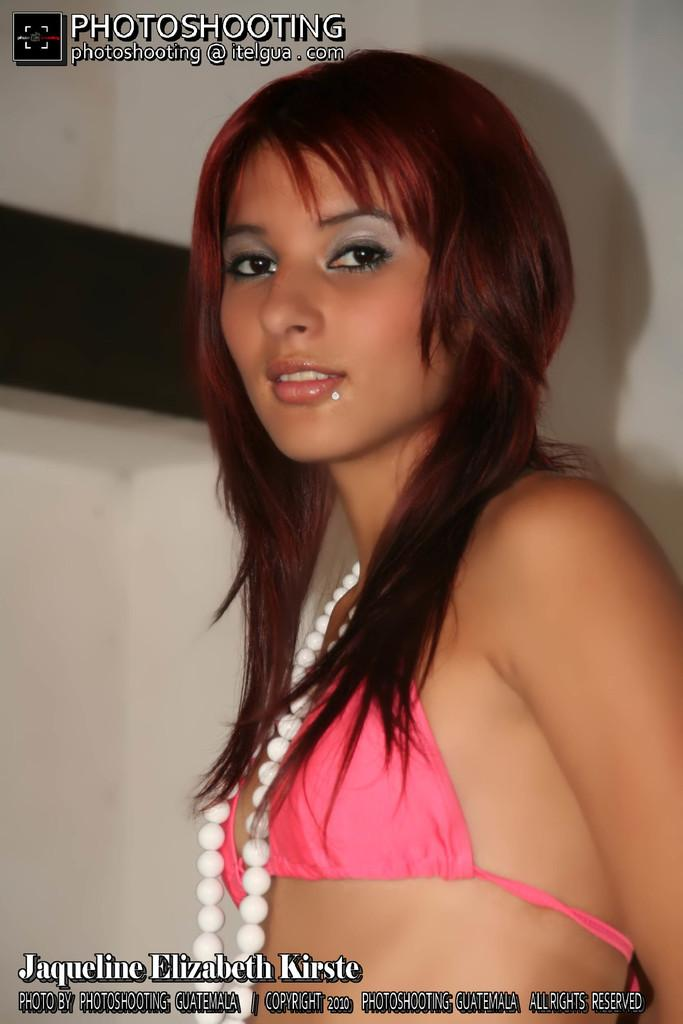Who is present in the image? There is a woman in the image. What can be seen in the background of the image? There is a wall visible in the image. What is written at the top of the image? There is text at the top of the image. What is written at the bottom of the image? There is text at the bottom of the image. What type of vase is hanging from the wire in the image? There is no vase or wire present in the image. What discovery was made by the woman in the image? The image does not depict any discovery made by the woman. 